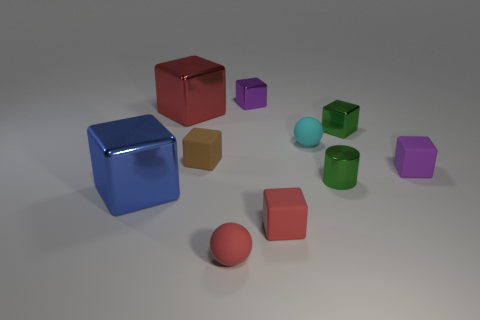There is a metal cube that is the same color as the tiny shiny cylinder; what size is it?
Your response must be concise. Small. Does the green thing that is in front of the purple rubber block have the same size as the shiny thing in front of the cylinder?
Provide a succinct answer. No. Is the color of the big cube that is behind the brown block the same as the rubber sphere left of the purple metal block?
Ensure brevity in your answer.  Yes. What number of metal things are green blocks or small green objects?
Your answer should be compact. 2. There is a tiny brown rubber object that is behind the tiny purple matte thing that is behind the large blue metallic thing; what shape is it?
Give a very brief answer. Cube. Is the tiny sphere to the left of the small cyan object made of the same material as the purple thing behind the tiny cyan sphere?
Offer a terse response. No. What number of brown matte cubes are in front of the block in front of the blue metal block?
Ensure brevity in your answer.  0. There is a rubber thing behind the small brown object; is its shape the same as the purple object that is in front of the small brown cube?
Give a very brief answer. No. There is a metallic object that is both in front of the red metal thing and left of the tiny red rubber ball; what is its size?
Keep it short and to the point. Large. What is the color of the other matte object that is the same shape as the tiny cyan rubber object?
Keep it short and to the point. Red. 